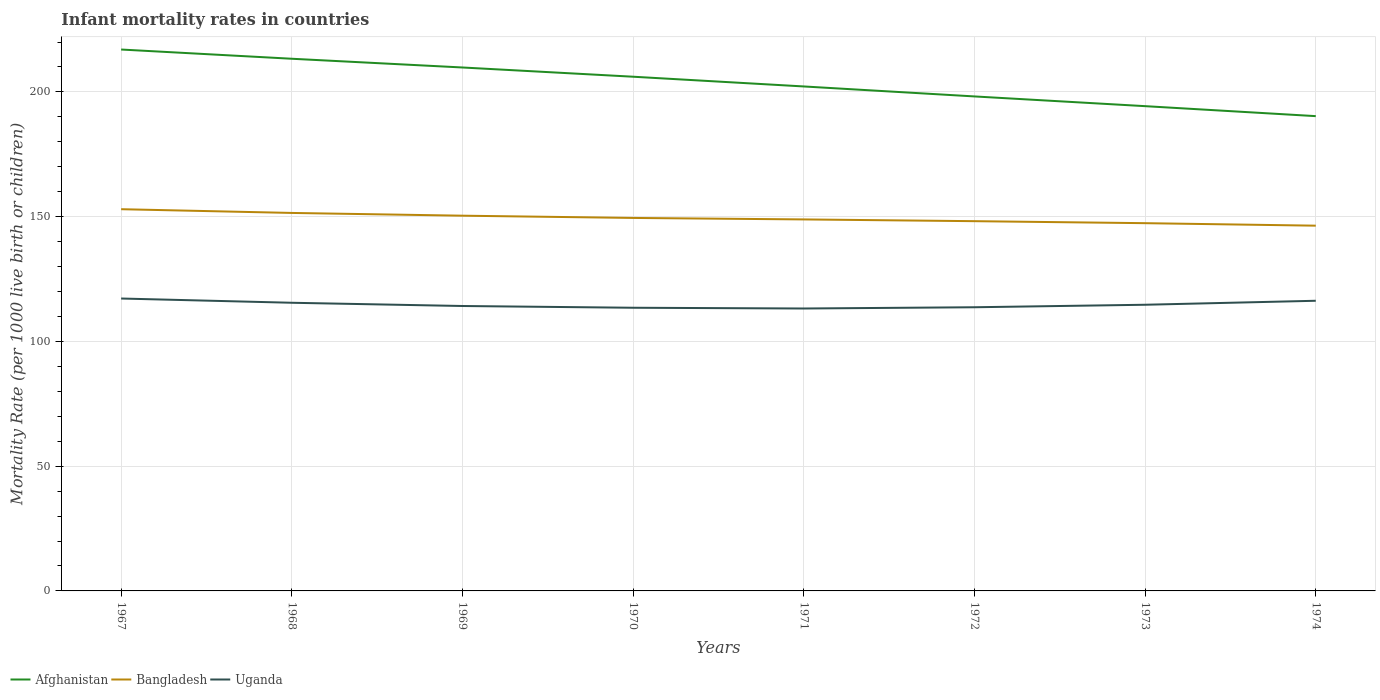How many different coloured lines are there?
Your answer should be very brief. 3. Does the line corresponding to Uganda intersect with the line corresponding to Bangladesh?
Provide a short and direct response. No. Across all years, what is the maximum infant mortality rate in Bangladesh?
Provide a short and direct response. 146.4. In which year was the infant mortality rate in Uganda maximum?
Your answer should be very brief. 1971. What is the total infant mortality rate in Bangladesh in the graph?
Give a very brief answer. 2.6. What is the difference between the highest and the second highest infant mortality rate in Uganda?
Ensure brevity in your answer.  4. What is the difference between the highest and the lowest infant mortality rate in Uganda?
Give a very brief answer. 3. Is the infant mortality rate in Bangladesh strictly greater than the infant mortality rate in Afghanistan over the years?
Provide a short and direct response. Yes. What is the difference between two consecutive major ticks on the Y-axis?
Your response must be concise. 50. Are the values on the major ticks of Y-axis written in scientific E-notation?
Keep it short and to the point. No. Does the graph contain any zero values?
Make the answer very short. No. Where does the legend appear in the graph?
Your answer should be compact. Bottom left. How many legend labels are there?
Provide a succinct answer. 3. How are the legend labels stacked?
Your answer should be very brief. Horizontal. What is the title of the graph?
Offer a very short reply. Infant mortality rates in countries. What is the label or title of the X-axis?
Ensure brevity in your answer.  Years. What is the label or title of the Y-axis?
Keep it short and to the point. Mortality Rate (per 1000 live birth or children). What is the Mortality Rate (per 1000 live birth or children) in Afghanistan in 1967?
Offer a very short reply. 217. What is the Mortality Rate (per 1000 live birth or children) of Bangladesh in 1967?
Keep it short and to the point. 153. What is the Mortality Rate (per 1000 live birth or children) of Uganda in 1967?
Ensure brevity in your answer.  117.2. What is the Mortality Rate (per 1000 live birth or children) of Afghanistan in 1968?
Provide a short and direct response. 213.3. What is the Mortality Rate (per 1000 live birth or children) of Bangladesh in 1968?
Make the answer very short. 151.5. What is the Mortality Rate (per 1000 live birth or children) of Uganda in 1968?
Your answer should be compact. 115.5. What is the Mortality Rate (per 1000 live birth or children) in Afghanistan in 1969?
Make the answer very short. 209.8. What is the Mortality Rate (per 1000 live birth or children) in Bangladesh in 1969?
Your response must be concise. 150.4. What is the Mortality Rate (per 1000 live birth or children) in Uganda in 1969?
Offer a very short reply. 114.2. What is the Mortality Rate (per 1000 live birth or children) of Afghanistan in 1970?
Provide a succinct answer. 206.1. What is the Mortality Rate (per 1000 live birth or children) in Bangladesh in 1970?
Keep it short and to the point. 149.5. What is the Mortality Rate (per 1000 live birth or children) in Uganda in 1970?
Give a very brief answer. 113.5. What is the Mortality Rate (per 1000 live birth or children) of Afghanistan in 1971?
Keep it short and to the point. 202.2. What is the Mortality Rate (per 1000 live birth or children) in Bangladesh in 1971?
Your answer should be very brief. 148.9. What is the Mortality Rate (per 1000 live birth or children) of Uganda in 1971?
Offer a terse response. 113.2. What is the Mortality Rate (per 1000 live birth or children) in Afghanistan in 1972?
Give a very brief answer. 198.2. What is the Mortality Rate (per 1000 live birth or children) of Bangladesh in 1972?
Your answer should be compact. 148.2. What is the Mortality Rate (per 1000 live birth or children) of Uganda in 1972?
Ensure brevity in your answer.  113.7. What is the Mortality Rate (per 1000 live birth or children) of Afghanistan in 1973?
Offer a very short reply. 194.3. What is the Mortality Rate (per 1000 live birth or children) of Bangladesh in 1973?
Offer a terse response. 147.4. What is the Mortality Rate (per 1000 live birth or children) of Uganda in 1973?
Offer a very short reply. 114.7. What is the Mortality Rate (per 1000 live birth or children) in Afghanistan in 1974?
Your answer should be very brief. 190.3. What is the Mortality Rate (per 1000 live birth or children) of Bangladesh in 1974?
Offer a terse response. 146.4. What is the Mortality Rate (per 1000 live birth or children) of Uganda in 1974?
Offer a terse response. 116.3. Across all years, what is the maximum Mortality Rate (per 1000 live birth or children) of Afghanistan?
Your answer should be very brief. 217. Across all years, what is the maximum Mortality Rate (per 1000 live birth or children) in Bangladesh?
Offer a very short reply. 153. Across all years, what is the maximum Mortality Rate (per 1000 live birth or children) of Uganda?
Your answer should be compact. 117.2. Across all years, what is the minimum Mortality Rate (per 1000 live birth or children) in Afghanistan?
Your response must be concise. 190.3. Across all years, what is the minimum Mortality Rate (per 1000 live birth or children) of Bangladesh?
Your answer should be compact. 146.4. Across all years, what is the minimum Mortality Rate (per 1000 live birth or children) in Uganda?
Your answer should be very brief. 113.2. What is the total Mortality Rate (per 1000 live birth or children) in Afghanistan in the graph?
Give a very brief answer. 1631.2. What is the total Mortality Rate (per 1000 live birth or children) of Bangladesh in the graph?
Offer a very short reply. 1195.3. What is the total Mortality Rate (per 1000 live birth or children) of Uganda in the graph?
Your answer should be very brief. 918.3. What is the difference between the Mortality Rate (per 1000 live birth or children) in Uganda in 1967 and that in 1969?
Ensure brevity in your answer.  3. What is the difference between the Mortality Rate (per 1000 live birth or children) of Afghanistan in 1967 and that in 1970?
Provide a short and direct response. 10.9. What is the difference between the Mortality Rate (per 1000 live birth or children) in Bangladesh in 1967 and that in 1970?
Give a very brief answer. 3.5. What is the difference between the Mortality Rate (per 1000 live birth or children) of Uganda in 1967 and that in 1970?
Your answer should be compact. 3.7. What is the difference between the Mortality Rate (per 1000 live birth or children) of Afghanistan in 1967 and that in 1971?
Make the answer very short. 14.8. What is the difference between the Mortality Rate (per 1000 live birth or children) in Bangladesh in 1967 and that in 1971?
Make the answer very short. 4.1. What is the difference between the Mortality Rate (per 1000 live birth or children) of Uganda in 1967 and that in 1971?
Offer a very short reply. 4. What is the difference between the Mortality Rate (per 1000 live birth or children) of Afghanistan in 1967 and that in 1972?
Ensure brevity in your answer.  18.8. What is the difference between the Mortality Rate (per 1000 live birth or children) of Bangladesh in 1967 and that in 1972?
Offer a very short reply. 4.8. What is the difference between the Mortality Rate (per 1000 live birth or children) of Uganda in 1967 and that in 1972?
Make the answer very short. 3.5. What is the difference between the Mortality Rate (per 1000 live birth or children) in Afghanistan in 1967 and that in 1973?
Your answer should be compact. 22.7. What is the difference between the Mortality Rate (per 1000 live birth or children) in Bangladesh in 1967 and that in 1973?
Keep it short and to the point. 5.6. What is the difference between the Mortality Rate (per 1000 live birth or children) of Uganda in 1967 and that in 1973?
Your response must be concise. 2.5. What is the difference between the Mortality Rate (per 1000 live birth or children) of Afghanistan in 1967 and that in 1974?
Your answer should be compact. 26.7. What is the difference between the Mortality Rate (per 1000 live birth or children) in Uganda in 1967 and that in 1974?
Provide a short and direct response. 0.9. What is the difference between the Mortality Rate (per 1000 live birth or children) in Afghanistan in 1968 and that in 1969?
Your answer should be very brief. 3.5. What is the difference between the Mortality Rate (per 1000 live birth or children) of Bangladesh in 1968 and that in 1969?
Provide a short and direct response. 1.1. What is the difference between the Mortality Rate (per 1000 live birth or children) in Uganda in 1968 and that in 1969?
Keep it short and to the point. 1.3. What is the difference between the Mortality Rate (per 1000 live birth or children) of Uganda in 1968 and that in 1970?
Your answer should be compact. 2. What is the difference between the Mortality Rate (per 1000 live birth or children) in Bangladesh in 1968 and that in 1971?
Offer a very short reply. 2.6. What is the difference between the Mortality Rate (per 1000 live birth or children) of Uganda in 1968 and that in 1971?
Offer a very short reply. 2.3. What is the difference between the Mortality Rate (per 1000 live birth or children) in Bangladesh in 1968 and that in 1973?
Offer a very short reply. 4.1. What is the difference between the Mortality Rate (per 1000 live birth or children) in Afghanistan in 1968 and that in 1974?
Ensure brevity in your answer.  23. What is the difference between the Mortality Rate (per 1000 live birth or children) of Uganda in 1968 and that in 1974?
Provide a short and direct response. -0.8. What is the difference between the Mortality Rate (per 1000 live birth or children) in Afghanistan in 1969 and that in 1970?
Give a very brief answer. 3.7. What is the difference between the Mortality Rate (per 1000 live birth or children) in Uganda in 1969 and that in 1970?
Offer a terse response. 0.7. What is the difference between the Mortality Rate (per 1000 live birth or children) of Afghanistan in 1969 and that in 1971?
Provide a short and direct response. 7.6. What is the difference between the Mortality Rate (per 1000 live birth or children) in Uganda in 1969 and that in 1971?
Your response must be concise. 1. What is the difference between the Mortality Rate (per 1000 live birth or children) of Bangladesh in 1969 and that in 1972?
Offer a very short reply. 2.2. What is the difference between the Mortality Rate (per 1000 live birth or children) of Uganda in 1969 and that in 1972?
Offer a very short reply. 0.5. What is the difference between the Mortality Rate (per 1000 live birth or children) of Afghanistan in 1969 and that in 1973?
Make the answer very short. 15.5. What is the difference between the Mortality Rate (per 1000 live birth or children) of Bangladesh in 1969 and that in 1973?
Make the answer very short. 3. What is the difference between the Mortality Rate (per 1000 live birth or children) in Uganda in 1969 and that in 1973?
Your answer should be very brief. -0.5. What is the difference between the Mortality Rate (per 1000 live birth or children) of Bangladesh in 1969 and that in 1974?
Ensure brevity in your answer.  4. What is the difference between the Mortality Rate (per 1000 live birth or children) in Bangladesh in 1970 and that in 1971?
Your answer should be very brief. 0.6. What is the difference between the Mortality Rate (per 1000 live birth or children) of Afghanistan in 1970 and that in 1972?
Your answer should be compact. 7.9. What is the difference between the Mortality Rate (per 1000 live birth or children) of Bangladesh in 1970 and that in 1972?
Your answer should be compact. 1.3. What is the difference between the Mortality Rate (per 1000 live birth or children) of Uganda in 1970 and that in 1972?
Provide a succinct answer. -0.2. What is the difference between the Mortality Rate (per 1000 live birth or children) in Afghanistan in 1970 and that in 1973?
Give a very brief answer. 11.8. What is the difference between the Mortality Rate (per 1000 live birth or children) in Uganda in 1970 and that in 1973?
Give a very brief answer. -1.2. What is the difference between the Mortality Rate (per 1000 live birth or children) in Afghanistan in 1970 and that in 1974?
Your response must be concise. 15.8. What is the difference between the Mortality Rate (per 1000 live birth or children) of Bangladesh in 1970 and that in 1974?
Offer a terse response. 3.1. What is the difference between the Mortality Rate (per 1000 live birth or children) in Uganda in 1970 and that in 1974?
Offer a very short reply. -2.8. What is the difference between the Mortality Rate (per 1000 live birth or children) of Afghanistan in 1971 and that in 1972?
Keep it short and to the point. 4. What is the difference between the Mortality Rate (per 1000 live birth or children) in Uganda in 1971 and that in 1972?
Provide a succinct answer. -0.5. What is the difference between the Mortality Rate (per 1000 live birth or children) of Bangladesh in 1971 and that in 1973?
Your answer should be compact. 1.5. What is the difference between the Mortality Rate (per 1000 live birth or children) of Uganda in 1971 and that in 1973?
Make the answer very short. -1.5. What is the difference between the Mortality Rate (per 1000 live birth or children) in Afghanistan in 1971 and that in 1974?
Provide a short and direct response. 11.9. What is the difference between the Mortality Rate (per 1000 live birth or children) in Bangladesh in 1971 and that in 1974?
Keep it short and to the point. 2.5. What is the difference between the Mortality Rate (per 1000 live birth or children) in Uganda in 1972 and that in 1973?
Provide a succinct answer. -1. What is the difference between the Mortality Rate (per 1000 live birth or children) in Afghanistan in 1972 and that in 1974?
Your answer should be compact. 7.9. What is the difference between the Mortality Rate (per 1000 live birth or children) of Afghanistan in 1967 and the Mortality Rate (per 1000 live birth or children) of Bangladesh in 1968?
Offer a very short reply. 65.5. What is the difference between the Mortality Rate (per 1000 live birth or children) in Afghanistan in 1967 and the Mortality Rate (per 1000 live birth or children) in Uganda in 1968?
Keep it short and to the point. 101.5. What is the difference between the Mortality Rate (per 1000 live birth or children) in Bangladesh in 1967 and the Mortality Rate (per 1000 live birth or children) in Uganda in 1968?
Your response must be concise. 37.5. What is the difference between the Mortality Rate (per 1000 live birth or children) of Afghanistan in 1967 and the Mortality Rate (per 1000 live birth or children) of Bangladesh in 1969?
Offer a very short reply. 66.6. What is the difference between the Mortality Rate (per 1000 live birth or children) of Afghanistan in 1967 and the Mortality Rate (per 1000 live birth or children) of Uganda in 1969?
Provide a short and direct response. 102.8. What is the difference between the Mortality Rate (per 1000 live birth or children) of Bangladesh in 1967 and the Mortality Rate (per 1000 live birth or children) of Uganda in 1969?
Make the answer very short. 38.8. What is the difference between the Mortality Rate (per 1000 live birth or children) of Afghanistan in 1967 and the Mortality Rate (per 1000 live birth or children) of Bangladesh in 1970?
Your answer should be very brief. 67.5. What is the difference between the Mortality Rate (per 1000 live birth or children) of Afghanistan in 1967 and the Mortality Rate (per 1000 live birth or children) of Uganda in 1970?
Your answer should be compact. 103.5. What is the difference between the Mortality Rate (per 1000 live birth or children) of Bangladesh in 1967 and the Mortality Rate (per 1000 live birth or children) of Uganda in 1970?
Make the answer very short. 39.5. What is the difference between the Mortality Rate (per 1000 live birth or children) in Afghanistan in 1967 and the Mortality Rate (per 1000 live birth or children) in Bangladesh in 1971?
Provide a succinct answer. 68.1. What is the difference between the Mortality Rate (per 1000 live birth or children) of Afghanistan in 1967 and the Mortality Rate (per 1000 live birth or children) of Uganda in 1971?
Keep it short and to the point. 103.8. What is the difference between the Mortality Rate (per 1000 live birth or children) of Bangladesh in 1967 and the Mortality Rate (per 1000 live birth or children) of Uganda in 1971?
Offer a very short reply. 39.8. What is the difference between the Mortality Rate (per 1000 live birth or children) in Afghanistan in 1967 and the Mortality Rate (per 1000 live birth or children) in Bangladesh in 1972?
Ensure brevity in your answer.  68.8. What is the difference between the Mortality Rate (per 1000 live birth or children) of Afghanistan in 1967 and the Mortality Rate (per 1000 live birth or children) of Uganda in 1972?
Make the answer very short. 103.3. What is the difference between the Mortality Rate (per 1000 live birth or children) in Bangladesh in 1967 and the Mortality Rate (per 1000 live birth or children) in Uganda in 1972?
Offer a terse response. 39.3. What is the difference between the Mortality Rate (per 1000 live birth or children) in Afghanistan in 1967 and the Mortality Rate (per 1000 live birth or children) in Bangladesh in 1973?
Ensure brevity in your answer.  69.6. What is the difference between the Mortality Rate (per 1000 live birth or children) in Afghanistan in 1967 and the Mortality Rate (per 1000 live birth or children) in Uganda in 1973?
Your response must be concise. 102.3. What is the difference between the Mortality Rate (per 1000 live birth or children) of Bangladesh in 1967 and the Mortality Rate (per 1000 live birth or children) of Uganda in 1973?
Ensure brevity in your answer.  38.3. What is the difference between the Mortality Rate (per 1000 live birth or children) in Afghanistan in 1967 and the Mortality Rate (per 1000 live birth or children) in Bangladesh in 1974?
Provide a short and direct response. 70.6. What is the difference between the Mortality Rate (per 1000 live birth or children) of Afghanistan in 1967 and the Mortality Rate (per 1000 live birth or children) of Uganda in 1974?
Keep it short and to the point. 100.7. What is the difference between the Mortality Rate (per 1000 live birth or children) of Bangladesh in 1967 and the Mortality Rate (per 1000 live birth or children) of Uganda in 1974?
Ensure brevity in your answer.  36.7. What is the difference between the Mortality Rate (per 1000 live birth or children) in Afghanistan in 1968 and the Mortality Rate (per 1000 live birth or children) in Bangladesh in 1969?
Give a very brief answer. 62.9. What is the difference between the Mortality Rate (per 1000 live birth or children) of Afghanistan in 1968 and the Mortality Rate (per 1000 live birth or children) of Uganda in 1969?
Your answer should be compact. 99.1. What is the difference between the Mortality Rate (per 1000 live birth or children) in Bangladesh in 1968 and the Mortality Rate (per 1000 live birth or children) in Uganda in 1969?
Offer a terse response. 37.3. What is the difference between the Mortality Rate (per 1000 live birth or children) in Afghanistan in 1968 and the Mortality Rate (per 1000 live birth or children) in Bangladesh in 1970?
Offer a terse response. 63.8. What is the difference between the Mortality Rate (per 1000 live birth or children) of Afghanistan in 1968 and the Mortality Rate (per 1000 live birth or children) of Uganda in 1970?
Offer a very short reply. 99.8. What is the difference between the Mortality Rate (per 1000 live birth or children) of Bangladesh in 1968 and the Mortality Rate (per 1000 live birth or children) of Uganda in 1970?
Your response must be concise. 38. What is the difference between the Mortality Rate (per 1000 live birth or children) of Afghanistan in 1968 and the Mortality Rate (per 1000 live birth or children) of Bangladesh in 1971?
Provide a short and direct response. 64.4. What is the difference between the Mortality Rate (per 1000 live birth or children) in Afghanistan in 1968 and the Mortality Rate (per 1000 live birth or children) in Uganda in 1971?
Your answer should be compact. 100.1. What is the difference between the Mortality Rate (per 1000 live birth or children) of Bangladesh in 1968 and the Mortality Rate (per 1000 live birth or children) of Uganda in 1971?
Your response must be concise. 38.3. What is the difference between the Mortality Rate (per 1000 live birth or children) in Afghanistan in 1968 and the Mortality Rate (per 1000 live birth or children) in Bangladesh in 1972?
Offer a terse response. 65.1. What is the difference between the Mortality Rate (per 1000 live birth or children) in Afghanistan in 1968 and the Mortality Rate (per 1000 live birth or children) in Uganda in 1972?
Make the answer very short. 99.6. What is the difference between the Mortality Rate (per 1000 live birth or children) in Bangladesh in 1968 and the Mortality Rate (per 1000 live birth or children) in Uganda in 1972?
Provide a succinct answer. 37.8. What is the difference between the Mortality Rate (per 1000 live birth or children) in Afghanistan in 1968 and the Mortality Rate (per 1000 live birth or children) in Bangladesh in 1973?
Make the answer very short. 65.9. What is the difference between the Mortality Rate (per 1000 live birth or children) of Afghanistan in 1968 and the Mortality Rate (per 1000 live birth or children) of Uganda in 1973?
Your response must be concise. 98.6. What is the difference between the Mortality Rate (per 1000 live birth or children) in Bangladesh in 1968 and the Mortality Rate (per 1000 live birth or children) in Uganda in 1973?
Provide a short and direct response. 36.8. What is the difference between the Mortality Rate (per 1000 live birth or children) in Afghanistan in 1968 and the Mortality Rate (per 1000 live birth or children) in Bangladesh in 1974?
Your answer should be very brief. 66.9. What is the difference between the Mortality Rate (per 1000 live birth or children) in Afghanistan in 1968 and the Mortality Rate (per 1000 live birth or children) in Uganda in 1974?
Ensure brevity in your answer.  97. What is the difference between the Mortality Rate (per 1000 live birth or children) in Bangladesh in 1968 and the Mortality Rate (per 1000 live birth or children) in Uganda in 1974?
Your answer should be very brief. 35.2. What is the difference between the Mortality Rate (per 1000 live birth or children) of Afghanistan in 1969 and the Mortality Rate (per 1000 live birth or children) of Bangladesh in 1970?
Provide a succinct answer. 60.3. What is the difference between the Mortality Rate (per 1000 live birth or children) of Afghanistan in 1969 and the Mortality Rate (per 1000 live birth or children) of Uganda in 1970?
Ensure brevity in your answer.  96.3. What is the difference between the Mortality Rate (per 1000 live birth or children) in Bangladesh in 1969 and the Mortality Rate (per 1000 live birth or children) in Uganda in 1970?
Ensure brevity in your answer.  36.9. What is the difference between the Mortality Rate (per 1000 live birth or children) in Afghanistan in 1969 and the Mortality Rate (per 1000 live birth or children) in Bangladesh in 1971?
Offer a very short reply. 60.9. What is the difference between the Mortality Rate (per 1000 live birth or children) of Afghanistan in 1969 and the Mortality Rate (per 1000 live birth or children) of Uganda in 1971?
Offer a very short reply. 96.6. What is the difference between the Mortality Rate (per 1000 live birth or children) of Bangladesh in 1969 and the Mortality Rate (per 1000 live birth or children) of Uganda in 1971?
Offer a terse response. 37.2. What is the difference between the Mortality Rate (per 1000 live birth or children) of Afghanistan in 1969 and the Mortality Rate (per 1000 live birth or children) of Bangladesh in 1972?
Your answer should be compact. 61.6. What is the difference between the Mortality Rate (per 1000 live birth or children) in Afghanistan in 1969 and the Mortality Rate (per 1000 live birth or children) in Uganda in 1972?
Provide a succinct answer. 96.1. What is the difference between the Mortality Rate (per 1000 live birth or children) in Bangladesh in 1969 and the Mortality Rate (per 1000 live birth or children) in Uganda in 1972?
Your response must be concise. 36.7. What is the difference between the Mortality Rate (per 1000 live birth or children) in Afghanistan in 1969 and the Mortality Rate (per 1000 live birth or children) in Bangladesh in 1973?
Offer a terse response. 62.4. What is the difference between the Mortality Rate (per 1000 live birth or children) in Afghanistan in 1969 and the Mortality Rate (per 1000 live birth or children) in Uganda in 1973?
Give a very brief answer. 95.1. What is the difference between the Mortality Rate (per 1000 live birth or children) of Bangladesh in 1969 and the Mortality Rate (per 1000 live birth or children) of Uganda in 1973?
Your answer should be compact. 35.7. What is the difference between the Mortality Rate (per 1000 live birth or children) of Afghanistan in 1969 and the Mortality Rate (per 1000 live birth or children) of Bangladesh in 1974?
Provide a succinct answer. 63.4. What is the difference between the Mortality Rate (per 1000 live birth or children) in Afghanistan in 1969 and the Mortality Rate (per 1000 live birth or children) in Uganda in 1974?
Your answer should be compact. 93.5. What is the difference between the Mortality Rate (per 1000 live birth or children) in Bangladesh in 1969 and the Mortality Rate (per 1000 live birth or children) in Uganda in 1974?
Offer a terse response. 34.1. What is the difference between the Mortality Rate (per 1000 live birth or children) of Afghanistan in 1970 and the Mortality Rate (per 1000 live birth or children) of Bangladesh in 1971?
Give a very brief answer. 57.2. What is the difference between the Mortality Rate (per 1000 live birth or children) of Afghanistan in 1970 and the Mortality Rate (per 1000 live birth or children) of Uganda in 1971?
Your answer should be very brief. 92.9. What is the difference between the Mortality Rate (per 1000 live birth or children) of Bangladesh in 1970 and the Mortality Rate (per 1000 live birth or children) of Uganda in 1971?
Your answer should be very brief. 36.3. What is the difference between the Mortality Rate (per 1000 live birth or children) in Afghanistan in 1970 and the Mortality Rate (per 1000 live birth or children) in Bangladesh in 1972?
Your answer should be very brief. 57.9. What is the difference between the Mortality Rate (per 1000 live birth or children) of Afghanistan in 1970 and the Mortality Rate (per 1000 live birth or children) of Uganda in 1972?
Make the answer very short. 92.4. What is the difference between the Mortality Rate (per 1000 live birth or children) of Bangladesh in 1970 and the Mortality Rate (per 1000 live birth or children) of Uganda in 1972?
Your answer should be very brief. 35.8. What is the difference between the Mortality Rate (per 1000 live birth or children) in Afghanistan in 1970 and the Mortality Rate (per 1000 live birth or children) in Bangladesh in 1973?
Your answer should be very brief. 58.7. What is the difference between the Mortality Rate (per 1000 live birth or children) of Afghanistan in 1970 and the Mortality Rate (per 1000 live birth or children) of Uganda in 1973?
Ensure brevity in your answer.  91.4. What is the difference between the Mortality Rate (per 1000 live birth or children) of Bangladesh in 1970 and the Mortality Rate (per 1000 live birth or children) of Uganda in 1973?
Your answer should be compact. 34.8. What is the difference between the Mortality Rate (per 1000 live birth or children) of Afghanistan in 1970 and the Mortality Rate (per 1000 live birth or children) of Bangladesh in 1974?
Make the answer very short. 59.7. What is the difference between the Mortality Rate (per 1000 live birth or children) in Afghanistan in 1970 and the Mortality Rate (per 1000 live birth or children) in Uganda in 1974?
Provide a short and direct response. 89.8. What is the difference between the Mortality Rate (per 1000 live birth or children) in Bangladesh in 1970 and the Mortality Rate (per 1000 live birth or children) in Uganda in 1974?
Make the answer very short. 33.2. What is the difference between the Mortality Rate (per 1000 live birth or children) in Afghanistan in 1971 and the Mortality Rate (per 1000 live birth or children) in Uganda in 1972?
Provide a succinct answer. 88.5. What is the difference between the Mortality Rate (per 1000 live birth or children) in Bangladesh in 1971 and the Mortality Rate (per 1000 live birth or children) in Uganda in 1972?
Give a very brief answer. 35.2. What is the difference between the Mortality Rate (per 1000 live birth or children) in Afghanistan in 1971 and the Mortality Rate (per 1000 live birth or children) in Bangladesh in 1973?
Your answer should be compact. 54.8. What is the difference between the Mortality Rate (per 1000 live birth or children) in Afghanistan in 1971 and the Mortality Rate (per 1000 live birth or children) in Uganda in 1973?
Ensure brevity in your answer.  87.5. What is the difference between the Mortality Rate (per 1000 live birth or children) of Bangladesh in 1971 and the Mortality Rate (per 1000 live birth or children) of Uganda in 1973?
Your answer should be very brief. 34.2. What is the difference between the Mortality Rate (per 1000 live birth or children) of Afghanistan in 1971 and the Mortality Rate (per 1000 live birth or children) of Bangladesh in 1974?
Provide a succinct answer. 55.8. What is the difference between the Mortality Rate (per 1000 live birth or children) of Afghanistan in 1971 and the Mortality Rate (per 1000 live birth or children) of Uganda in 1974?
Your response must be concise. 85.9. What is the difference between the Mortality Rate (per 1000 live birth or children) of Bangladesh in 1971 and the Mortality Rate (per 1000 live birth or children) of Uganda in 1974?
Offer a very short reply. 32.6. What is the difference between the Mortality Rate (per 1000 live birth or children) in Afghanistan in 1972 and the Mortality Rate (per 1000 live birth or children) in Bangladesh in 1973?
Provide a succinct answer. 50.8. What is the difference between the Mortality Rate (per 1000 live birth or children) in Afghanistan in 1972 and the Mortality Rate (per 1000 live birth or children) in Uganda in 1973?
Provide a succinct answer. 83.5. What is the difference between the Mortality Rate (per 1000 live birth or children) in Bangladesh in 1972 and the Mortality Rate (per 1000 live birth or children) in Uganda in 1973?
Offer a very short reply. 33.5. What is the difference between the Mortality Rate (per 1000 live birth or children) in Afghanistan in 1972 and the Mortality Rate (per 1000 live birth or children) in Bangladesh in 1974?
Provide a short and direct response. 51.8. What is the difference between the Mortality Rate (per 1000 live birth or children) in Afghanistan in 1972 and the Mortality Rate (per 1000 live birth or children) in Uganda in 1974?
Offer a very short reply. 81.9. What is the difference between the Mortality Rate (per 1000 live birth or children) of Bangladesh in 1972 and the Mortality Rate (per 1000 live birth or children) of Uganda in 1974?
Offer a terse response. 31.9. What is the difference between the Mortality Rate (per 1000 live birth or children) of Afghanistan in 1973 and the Mortality Rate (per 1000 live birth or children) of Bangladesh in 1974?
Provide a short and direct response. 47.9. What is the difference between the Mortality Rate (per 1000 live birth or children) of Bangladesh in 1973 and the Mortality Rate (per 1000 live birth or children) of Uganda in 1974?
Provide a succinct answer. 31.1. What is the average Mortality Rate (per 1000 live birth or children) of Afghanistan per year?
Your response must be concise. 203.9. What is the average Mortality Rate (per 1000 live birth or children) of Bangladesh per year?
Offer a terse response. 149.41. What is the average Mortality Rate (per 1000 live birth or children) of Uganda per year?
Offer a very short reply. 114.79. In the year 1967, what is the difference between the Mortality Rate (per 1000 live birth or children) in Afghanistan and Mortality Rate (per 1000 live birth or children) in Uganda?
Your answer should be compact. 99.8. In the year 1967, what is the difference between the Mortality Rate (per 1000 live birth or children) of Bangladesh and Mortality Rate (per 1000 live birth or children) of Uganda?
Ensure brevity in your answer.  35.8. In the year 1968, what is the difference between the Mortality Rate (per 1000 live birth or children) in Afghanistan and Mortality Rate (per 1000 live birth or children) in Bangladesh?
Provide a short and direct response. 61.8. In the year 1968, what is the difference between the Mortality Rate (per 1000 live birth or children) of Afghanistan and Mortality Rate (per 1000 live birth or children) of Uganda?
Offer a terse response. 97.8. In the year 1969, what is the difference between the Mortality Rate (per 1000 live birth or children) in Afghanistan and Mortality Rate (per 1000 live birth or children) in Bangladesh?
Offer a very short reply. 59.4. In the year 1969, what is the difference between the Mortality Rate (per 1000 live birth or children) in Afghanistan and Mortality Rate (per 1000 live birth or children) in Uganda?
Offer a terse response. 95.6. In the year 1969, what is the difference between the Mortality Rate (per 1000 live birth or children) in Bangladesh and Mortality Rate (per 1000 live birth or children) in Uganda?
Your answer should be compact. 36.2. In the year 1970, what is the difference between the Mortality Rate (per 1000 live birth or children) in Afghanistan and Mortality Rate (per 1000 live birth or children) in Bangladesh?
Ensure brevity in your answer.  56.6. In the year 1970, what is the difference between the Mortality Rate (per 1000 live birth or children) of Afghanistan and Mortality Rate (per 1000 live birth or children) of Uganda?
Your answer should be compact. 92.6. In the year 1970, what is the difference between the Mortality Rate (per 1000 live birth or children) in Bangladesh and Mortality Rate (per 1000 live birth or children) in Uganda?
Provide a short and direct response. 36. In the year 1971, what is the difference between the Mortality Rate (per 1000 live birth or children) in Afghanistan and Mortality Rate (per 1000 live birth or children) in Bangladesh?
Provide a short and direct response. 53.3. In the year 1971, what is the difference between the Mortality Rate (per 1000 live birth or children) of Afghanistan and Mortality Rate (per 1000 live birth or children) of Uganda?
Provide a short and direct response. 89. In the year 1971, what is the difference between the Mortality Rate (per 1000 live birth or children) of Bangladesh and Mortality Rate (per 1000 live birth or children) of Uganda?
Keep it short and to the point. 35.7. In the year 1972, what is the difference between the Mortality Rate (per 1000 live birth or children) of Afghanistan and Mortality Rate (per 1000 live birth or children) of Uganda?
Offer a very short reply. 84.5. In the year 1972, what is the difference between the Mortality Rate (per 1000 live birth or children) of Bangladesh and Mortality Rate (per 1000 live birth or children) of Uganda?
Your answer should be very brief. 34.5. In the year 1973, what is the difference between the Mortality Rate (per 1000 live birth or children) in Afghanistan and Mortality Rate (per 1000 live birth or children) in Bangladesh?
Offer a terse response. 46.9. In the year 1973, what is the difference between the Mortality Rate (per 1000 live birth or children) of Afghanistan and Mortality Rate (per 1000 live birth or children) of Uganda?
Your answer should be compact. 79.6. In the year 1973, what is the difference between the Mortality Rate (per 1000 live birth or children) in Bangladesh and Mortality Rate (per 1000 live birth or children) in Uganda?
Offer a terse response. 32.7. In the year 1974, what is the difference between the Mortality Rate (per 1000 live birth or children) of Afghanistan and Mortality Rate (per 1000 live birth or children) of Bangladesh?
Your answer should be compact. 43.9. In the year 1974, what is the difference between the Mortality Rate (per 1000 live birth or children) in Afghanistan and Mortality Rate (per 1000 live birth or children) in Uganda?
Your response must be concise. 74. In the year 1974, what is the difference between the Mortality Rate (per 1000 live birth or children) of Bangladesh and Mortality Rate (per 1000 live birth or children) of Uganda?
Your response must be concise. 30.1. What is the ratio of the Mortality Rate (per 1000 live birth or children) in Afghanistan in 1967 to that in 1968?
Make the answer very short. 1.02. What is the ratio of the Mortality Rate (per 1000 live birth or children) of Bangladesh in 1967 to that in 1968?
Provide a succinct answer. 1.01. What is the ratio of the Mortality Rate (per 1000 live birth or children) of Uganda in 1967 to that in 1968?
Keep it short and to the point. 1.01. What is the ratio of the Mortality Rate (per 1000 live birth or children) of Afghanistan in 1967 to that in 1969?
Provide a succinct answer. 1.03. What is the ratio of the Mortality Rate (per 1000 live birth or children) in Bangladesh in 1967 to that in 1969?
Offer a very short reply. 1.02. What is the ratio of the Mortality Rate (per 1000 live birth or children) of Uganda in 1967 to that in 1969?
Your answer should be very brief. 1.03. What is the ratio of the Mortality Rate (per 1000 live birth or children) of Afghanistan in 1967 to that in 1970?
Provide a succinct answer. 1.05. What is the ratio of the Mortality Rate (per 1000 live birth or children) of Bangladesh in 1967 to that in 1970?
Provide a short and direct response. 1.02. What is the ratio of the Mortality Rate (per 1000 live birth or children) of Uganda in 1967 to that in 1970?
Provide a short and direct response. 1.03. What is the ratio of the Mortality Rate (per 1000 live birth or children) of Afghanistan in 1967 to that in 1971?
Ensure brevity in your answer.  1.07. What is the ratio of the Mortality Rate (per 1000 live birth or children) of Bangladesh in 1967 to that in 1971?
Give a very brief answer. 1.03. What is the ratio of the Mortality Rate (per 1000 live birth or children) of Uganda in 1967 to that in 1971?
Keep it short and to the point. 1.04. What is the ratio of the Mortality Rate (per 1000 live birth or children) in Afghanistan in 1967 to that in 1972?
Provide a short and direct response. 1.09. What is the ratio of the Mortality Rate (per 1000 live birth or children) of Bangladesh in 1967 to that in 1972?
Your answer should be compact. 1.03. What is the ratio of the Mortality Rate (per 1000 live birth or children) in Uganda in 1967 to that in 1972?
Make the answer very short. 1.03. What is the ratio of the Mortality Rate (per 1000 live birth or children) in Afghanistan in 1967 to that in 1973?
Ensure brevity in your answer.  1.12. What is the ratio of the Mortality Rate (per 1000 live birth or children) in Bangladesh in 1967 to that in 1973?
Make the answer very short. 1.04. What is the ratio of the Mortality Rate (per 1000 live birth or children) of Uganda in 1967 to that in 1973?
Provide a succinct answer. 1.02. What is the ratio of the Mortality Rate (per 1000 live birth or children) of Afghanistan in 1967 to that in 1974?
Your response must be concise. 1.14. What is the ratio of the Mortality Rate (per 1000 live birth or children) in Bangladesh in 1967 to that in 1974?
Give a very brief answer. 1.05. What is the ratio of the Mortality Rate (per 1000 live birth or children) of Uganda in 1967 to that in 1974?
Offer a terse response. 1.01. What is the ratio of the Mortality Rate (per 1000 live birth or children) of Afghanistan in 1968 to that in 1969?
Your response must be concise. 1.02. What is the ratio of the Mortality Rate (per 1000 live birth or children) in Bangladesh in 1968 to that in 1969?
Give a very brief answer. 1.01. What is the ratio of the Mortality Rate (per 1000 live birth or children) of Uganda in 1968 to that in 1969?
Your answer should be very brief. 1.01. What is the ratio of the Mortality Rate (per 1000 live birth or children) in Afghanistan in 1968 to that in 1970?
Your answer should be compact. 1.03. What is the ratio of the Mortality Rate (per 1000 live birth or children) of Bangladesh in 1968 to that in 1970?
Make the answer very short. 1.01. What is the ratio of the Mortality Rate (per 1000 live birth or children) of Uganda in 1968 to that in 1970?
Make the answer very short. 1.02. What is the ratio of the Mortality Rate (per 1000 live birth or children) in Afghanistan in 1968 to that in 1971?
Provide a succinct answer. 1.05. What is the ratio of the Mortality Rate (per 1000 live birth or children) in Bangladesh in 1968 to that in 1971?
Your answer should be compact. 1.02. What is the ratio of the Mortality Rate (per 1000 live birth or children) in Uganda in 1968 to that in 1971?
Make the answer very short. 1.02. What is the ratio of the Mortality Rate (per 1000 live birth or children) in Afghanistan in 1968 to that in 1972?
Give a very brief answer. 1.08. What is the ratio of the Mortality Rate (per 1000 live birth or children) of Bangladesh in 1968 to that in 1972?
Offer a very short reply. 1.02. What is the ratio of the Mortality Rate (per 1000 live birth or children) of Uganda in 1968 to that in 1972?
Your answer should be very brief. 1.02. What is the ratio of the Mortality Rate (per 1000 live birth or children) of Afghanistan in 1968 to that in 1973?
Provide a short and direct response. 1.1. What is the ratio of the Mortality Rate (per 1000 live birth or children) in Bangladesh in 1968 to that in 1973?
Offer a very short reply. 1.03. What is the ratio of the Mortality Rate (per 1000 live birth or children) of Afghanistan in 1968 to that in 1974?
Offer a very short reply. 1.12. What is the ratio of the Mortality Rate (per 1000 live birth or children) in Bangladesh in 1968 to that in 1974?
Offer a very short reply. 1.03. What is the ratio of the Mortality Rate (per 1000 live birth or children) of Afghanistan in 1969 to that in 1970?
Your answer should be very brief. 1.02. What is the ratio of the Mortality Rate (per 1000 live birth or children) in Uganda in 1969 to that in 1970?
Offer a terse response. 1.01. What is the ratio of the Mortality Rate (per 1000 live birth or children) in Afghanistan in 1969 to that in 1971?
Make the answer very short. 1.04. What is the ratio of the Mortality Rate (per 1000 live birth or children) of Uganda in 1969 to that in 1971?
Keep it short and to the point. 1.01. What is the ratio of the Mortality Rate (per 1000 live birth or children) in Afghanistan in 1969 to that in 1972?
Offer a terse response. 1.06. What is the ratio of the Mortality Rate (per 1000 live birth or children) in Bangladesh in 1969 to that in 1972?
Your response must be concise. 1.01. What is the ratio of the Mortality Rate (per 1000 live birth or children) of Afghanistan in 1969 to that in 1973?
Your answer should be compact. 1.08. What is the ratio of the Mortality Rate (per 1000 live birth or children) of Bangladesh in 1969 to that in 1973?
Give a very brief answer. 1.02. What is the ratio of the Mortality Rate (per 1000 live birth or children) of Afghanistan in 1969 to that in 1974?
Your answer should be very brief. 1.1. What is the ratio of the Mortality Rate (per 1000 live birth or children) in Bangladesh in 1969 to that in 1974?
Give a very brief answer. 1.03. What is the ratio of the Mortality Rate (per 1000 live birth or children) of Uganda in 1969 to that in 1974?
Provide a succinct answer. 0.98. What is the ratio of the Mortality Rate (per 1000 live birth or children) in Afghanistan in 1970 to that in 1971?
Ensure brevity in your answer.  1.02. What is the ratio of the Mortality Rate (per 1000 live birth or children) in Uganda in 1970 to that in 1971?
Give a very brief answer. 1. What is the ratio of the Mortality Rate (per 1000 live birth or children) in Afghanistan in 1970 to that in 1972?
Ensure brevity in your answer.  1.04. What is the ratio of the Mortality Rate (per 1000 live birth or children) in Bangladesh in 1970 to that in 1972?
Your answer should be compact. 1.01. What is the ratio of the Mortality Rate (per 1000 live birth or children) in Uganda in 1970 to that in 1972?
Keep it short and to the point. 1. What is the ratio of the Mortality Rate (per 1000 live birth or children) of Afghanistan in 1970 to that in 1973?
Give a very brief answer. 1.06. What is the ratio of the Mortality Rate (per 1000 live birth or children) of Bangladesh in 1970 to that in 1973?
Your answer should be very brief. 1.01. What is the ratio of the Mortality Rate (per 1000 live birth or children) of Afghanistan in 1970 to that in 1974?
Offer a terse response. 1.08. What is the ratio of the Mortality Rate (per 1000 live birth or children) of Bangladesh in 1970 to that in 1974?
Provide a short and direct response. 1.02. What is the ratio of the Mortality Rate (per 1000 live birth or children) of Uganda in 1970 to that in 1974?
Your answer should be compact. 0.98. What is the ratio of the Mortality Rate (per 1000 live birth or children) in Afghanistan in 1971 to that in 1972?
Ensure brevity in your answer.  1.02. What is the ratio of the Mortality Rate (per 1000 live birth or children) in Bangladesh in 1971 to that in 1972?
Your response must be concise. 1. What is the ratio of the Mortality Rate (per 1000 live birth or children) in Uganda in 1971 to that in 1972?
Your response must be concise. 1. What is the ratio of the Mortality Rate (per 1000 live birth or children) in Afghanistan in 1971 to that in 1973?
Make the answer very short. 1.04. What is the ratio of the Mortality Rate (per 1000 live birth or children) in Bangladesh in 1971 to that in 1973?
Your answer should be compact. 1.01. What is the ratio of the Mortality Rate (per 1000 live birth or children) of Uganda in 1971 to that in 1973?
Ensure brevity in your answer.  0.99. What is the ratio of the Mortality Rate (per 1000 live birth or children) of Afghanistan in 1971 to that in 1974?
Keep it short and to the point. 1.06. What is the ratio of the Mortality Rate (per 1000 live birth or children) of Bangladesh in 1971 to that in 1974?
Offer a very short reply. 1.02. What is the ratio of the Mortality Rate (per 1000 live birth or children) of Uganda in 1971 to that in 1974?
Provide a succinct answer. 0.97. What is the ratio of the Mortality Rate (per 1000 live birth or children) in Afghanistan in 1972 to that in 1973?
Your answer should be very brief. 1.02. What is the ratio of the Mortality Rate (per 1000 live birth or children) of Bangladesh in 1972 to that in 1973?
Provide a succinct answer. 1.01. What is the ratio of the Mortality Rate (per 1000 live birth or children) in Afghanistan in 1972 to that in 1974?
Provide a short and direct response. 1.04. What is the ratio of the Mortality Rate (per 1000 live birth or children) of Bangladesh in 1972 to that in 1974?
Your answer should be very brief. 1.01. What is the ratio of the Mortality Rate (per 1000 live birth or children) in Uganda in 1972 to that in 1974?
Your answer should be compact. 0.98. What is the ratio of the Mortality Rate (per 1000 live birth or children) of Bangladesh in 1973 to that in 1974?
Give a very brief answer. 1.01. What is the ratio of the Mortality Rate (per 1000 live birth or children) in Uganda in 1973 to that in 1974?
Give a very brief answer. 0.99. What is the difference between the highest and the second highest Mortality Rate (per 1000 live birth or children) of Afghanistan?
Your answer should be compact. 3.7. What is the difference between the highest and the second highest Mortality Rate (per 1000 live birth or children) of Uganda?
Make the answer very short. 0.9. What is the difference between the highest and the lowest Mortality Rate (per 1000 live birth or children) of Afghanistan?
Your answer should be very brief. 26.7. What is the difference between the highest and the lowest Mortality Rate (per 1000 live birth or children) in Bangladesh?
Your response must be concise. 6.6. 